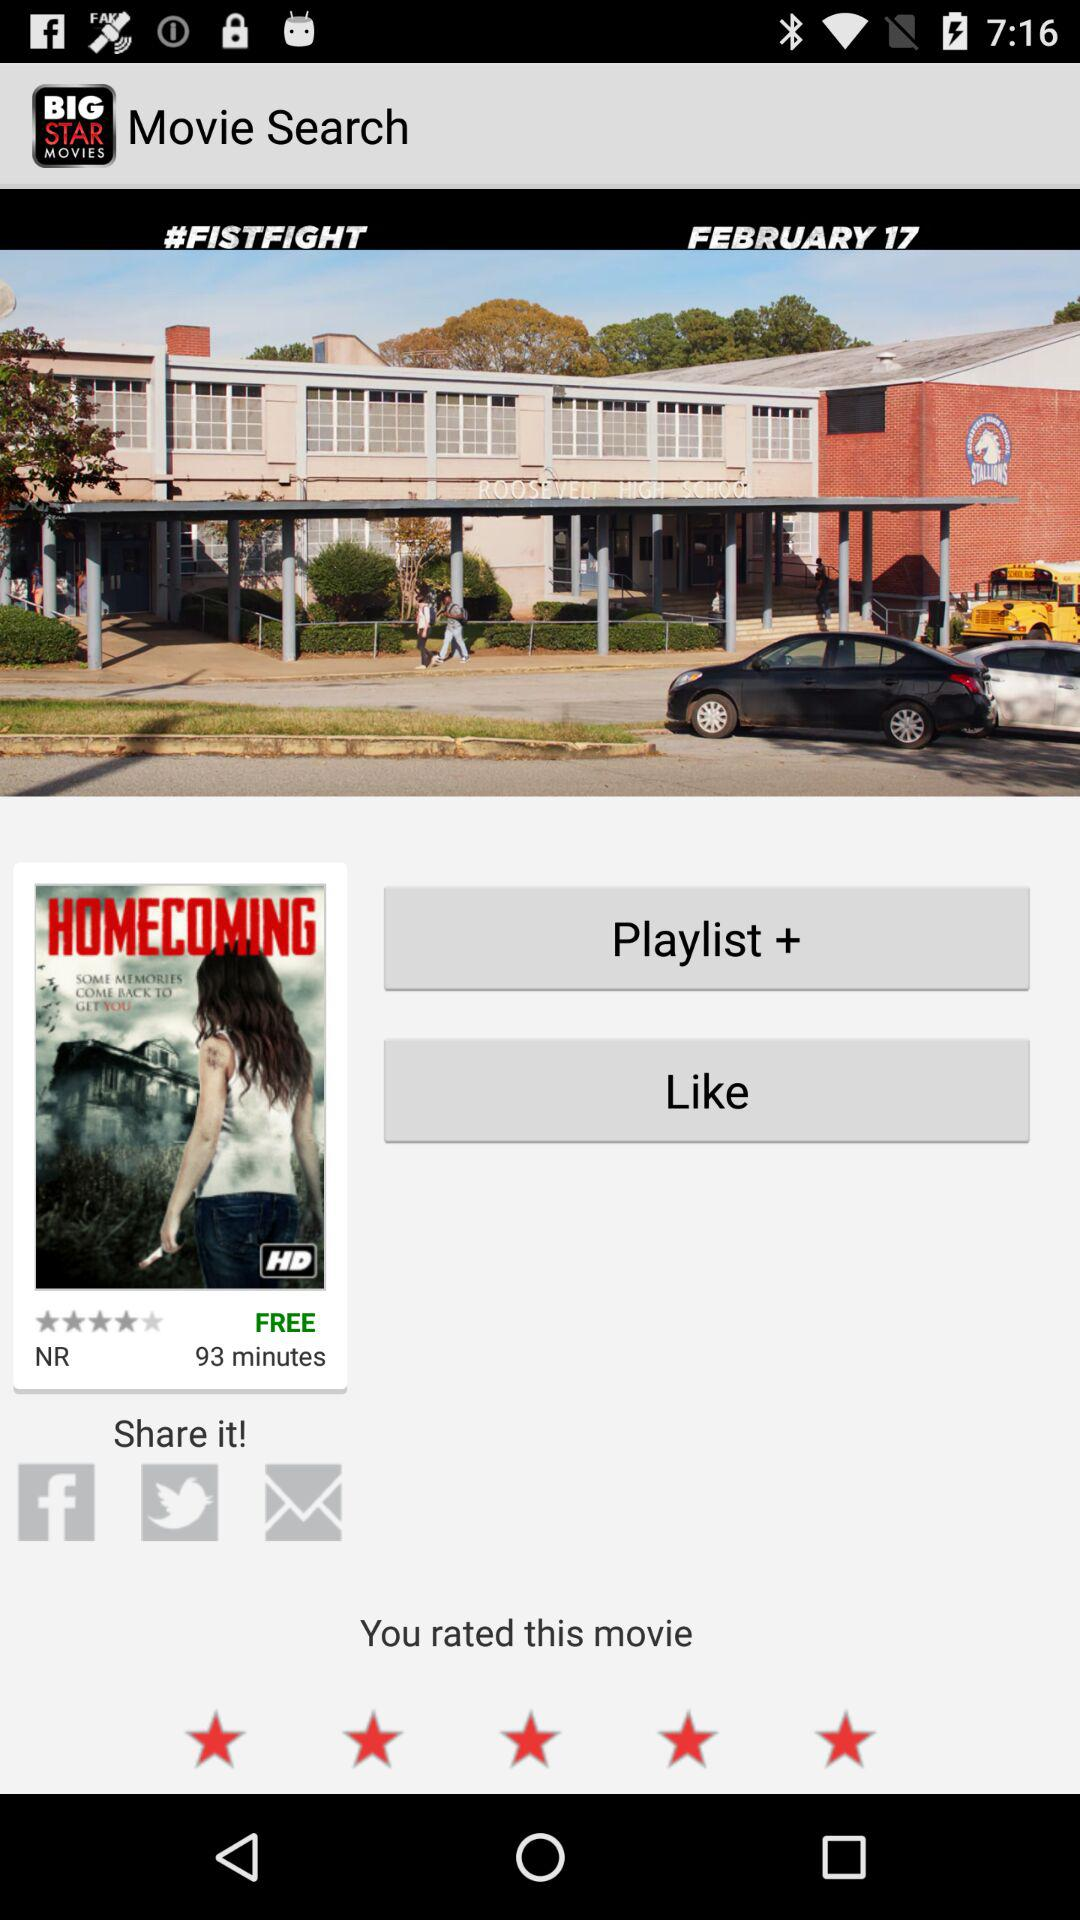What is the rating of the movie? The rating of the movie is 4 stars. 